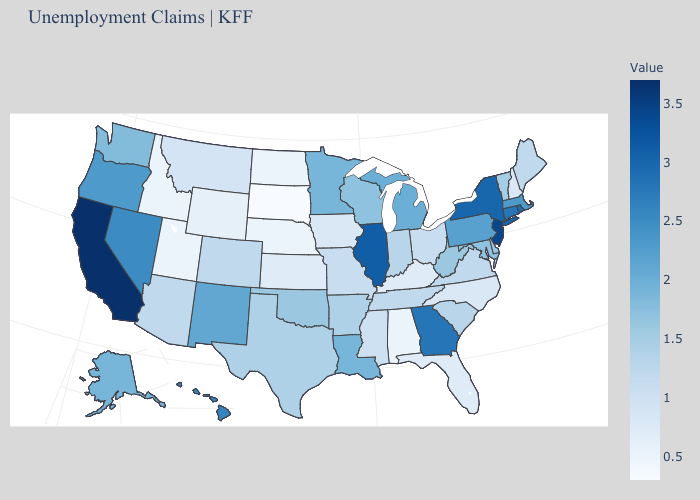Which states have the lowest value in the South?
Answer briefly. Alabama. Which states have the lowest value in the MidWest?
Concise answer only. South Dakota. Does the map have missing data?
Answer briefly. No. Among the states that border Colorado , which have the lowest value?
Concise answer only. Nebraska, Utah. Which states hav the highest value in the West?
Quick response, please. California. 